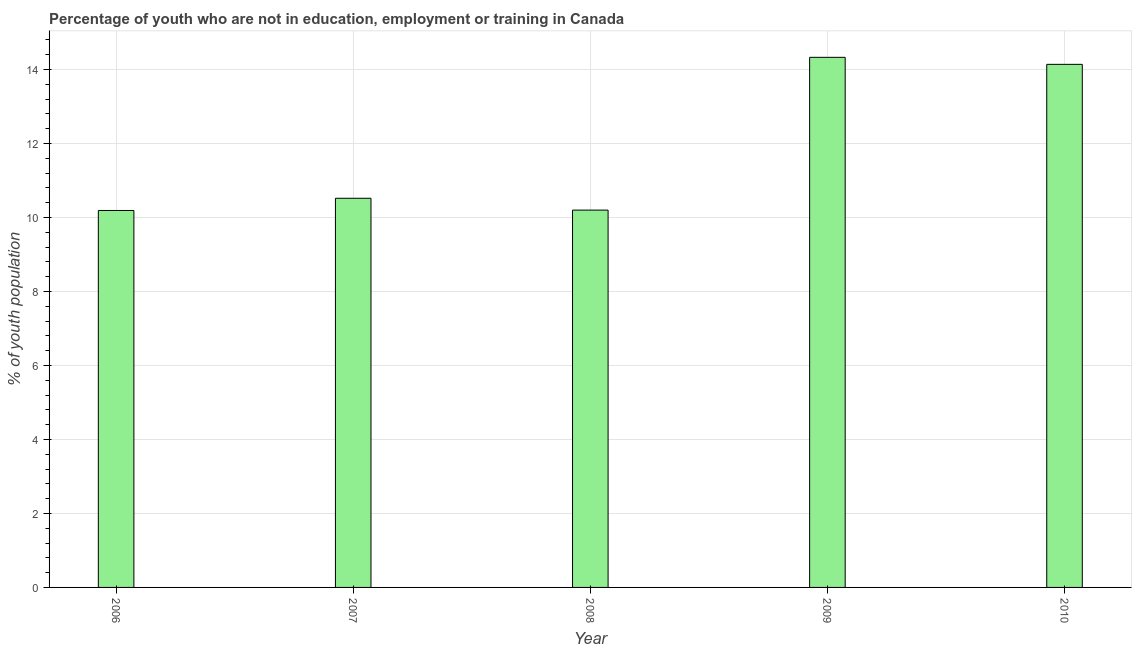Does the graph contain any zero values?
Give a very brief answer. No. What is the title of the graph?
Keep it short and to the point. Percentage of youth who are not in education, employment or training in Canada. What is the label or title of the X-axis?
Provide a succinct answer. Year. What is the label or title of the Y-axis?
Your response must be concise. % of youth population. What is the unemployed youth population in 2006?
Make the answer very short. 10.19. Across all years, what is the maximum unemployed youth population?
Offer a terse response. 14.33. Across all years, what is the minimum unemployed youth population?
Offer a terse response. 10.19. What is the sum of the unemployed youth population?
Your answer should be compact. 59.38. What is the difference between the unemployed youth population in 2008 and 2010?
Make the answer very short. -3.94. What is the average unemployed youth population per year?
Give a very brief answer. 11.88. What is the median unemployed youth population?
Offer a terse response. 10.52. In how many years, is the unemployed youth population greater than 14 %?
Keep it short and to the point. 2. Do a majority of the years between 2008 and 2007 (inclusive) have unemployed youth population greater than 10 %?
Your answer should be compact. No. What is the ratio of the unemployed youth population in 2007 to that in 2010?
Make the answer very short. 0.74. What is the difference between the highest and the second highest unemployed youth population?
Offer a terse response. 0.19. What is the difference between the highest and the lowest unemployed youth population?
Ensure brevity in your answer.  4.14. Are all the bars in the graph horizontal?
Provide a succinct answer. No. What is the % of youth population of 2006?
Offer a very short reply. 10.19. What is the % of youth population in 2007?
Give a very brief answer. 10.52. What is the % of youth population of 2008?
Your answer should be very brief. 10.2. What is the % of youth population of 2009?
Your answer should be compact. 14.33. What is the % of youth population in 2010?
Your response must be concise. 14.14. What is the difference between the % of youth population in 2006 and 2007?
Offer a very short reply. -0.33. What is the difference between the % of youth population in 2006 and 2008?
Give a very brief answer. -0.01. What is the difference between the % of youth population in 2006 and 2009?
Your answer should be compact. -4.14. What is the difference between the % of youth population in 2006 and 2010?
Make the answer very short. -3.95. What is the difference between the % of youth population in 2007 and 2008?
Ensure brevity in your answer.  0.32. What is the difference between the % of youth population in 2007 and 2009?
Make the answer very short. -3.81. What is the difference between the % of youth population in 2007 and 2010?
Your answer should be very brief. -3.62. What is the difference between the % of youth population in 2008 and 2009?
Your response must be concise. -4.13. What is the difference between the % of youth population in 2008 and 2010?
Your answer should be very brief. -3.94. What is the difference between the % of youth population in 2009 and 2010?
Give a very brief answer. 0.19. What is the ratio of the % of youth population in 2006 to that in 2009?
Provide a succinct answer. 0.71. What is the ratio of the % of youth population in 2006 to that in 2010?
Make the answer very short. 0.72. What is the ratio of the % of youth population in 2007 to that in 2008?
Your response must be concise. 1.03. What is the ratio of the % of youth population in 2007 to that in 2009?
Offer a terse response. 0.73. What is the ratio of the % of youth population in 2007 to that in 2010?
Provide a short and direct response. 0.74. What is the ratio of the % of youth population in 2008 to that in 2009?
Your response must be concise. 0.71. What is the ratio of the % of youth population in 2008 to that in 2010?
Your answer should be compact. 0.72. What is the ratio of the % of youth population in 2009 to that in 2010?
Your answer should be compact. 1.01. 